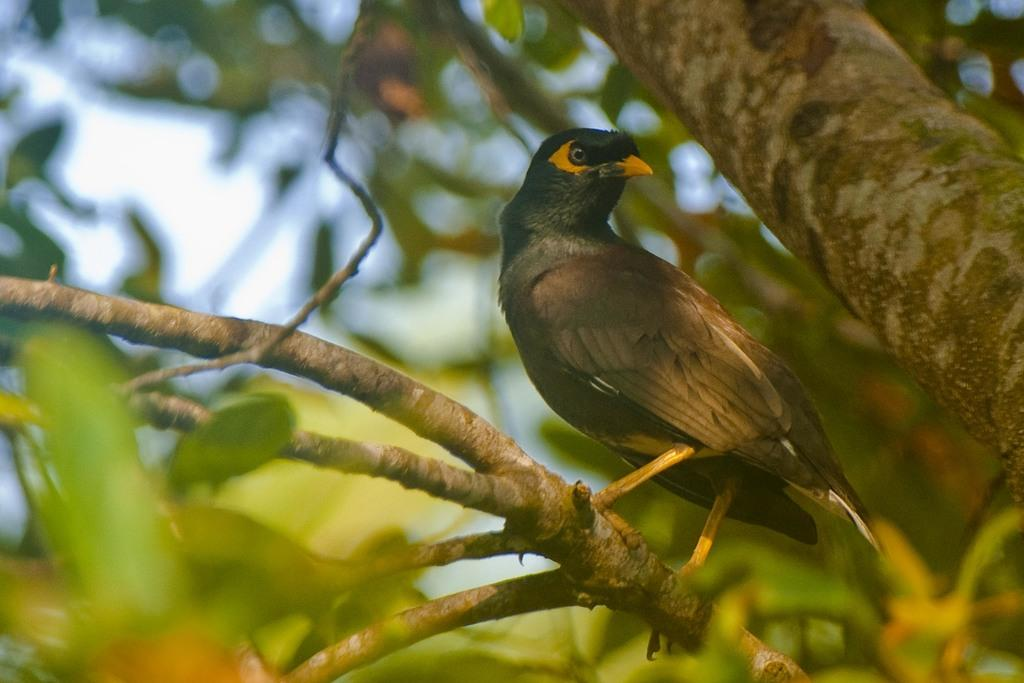What type of bird can be seen in the image? There is a black color bird in the image. Where is the bird located? The bird is on a stem of a tree. What can be seen on the right side of the image? There is a trunk on the right side of the image. What type of vegetation is visible in the background of the image? Few leaves are visible in the background of the image. What type of club can be seen in the image? There is no club present in the image; it features a black color bird on a tree stem. What is the bird learning in the image? The image does not depict the bird learning anything; it is simply perched on a tree stem. 